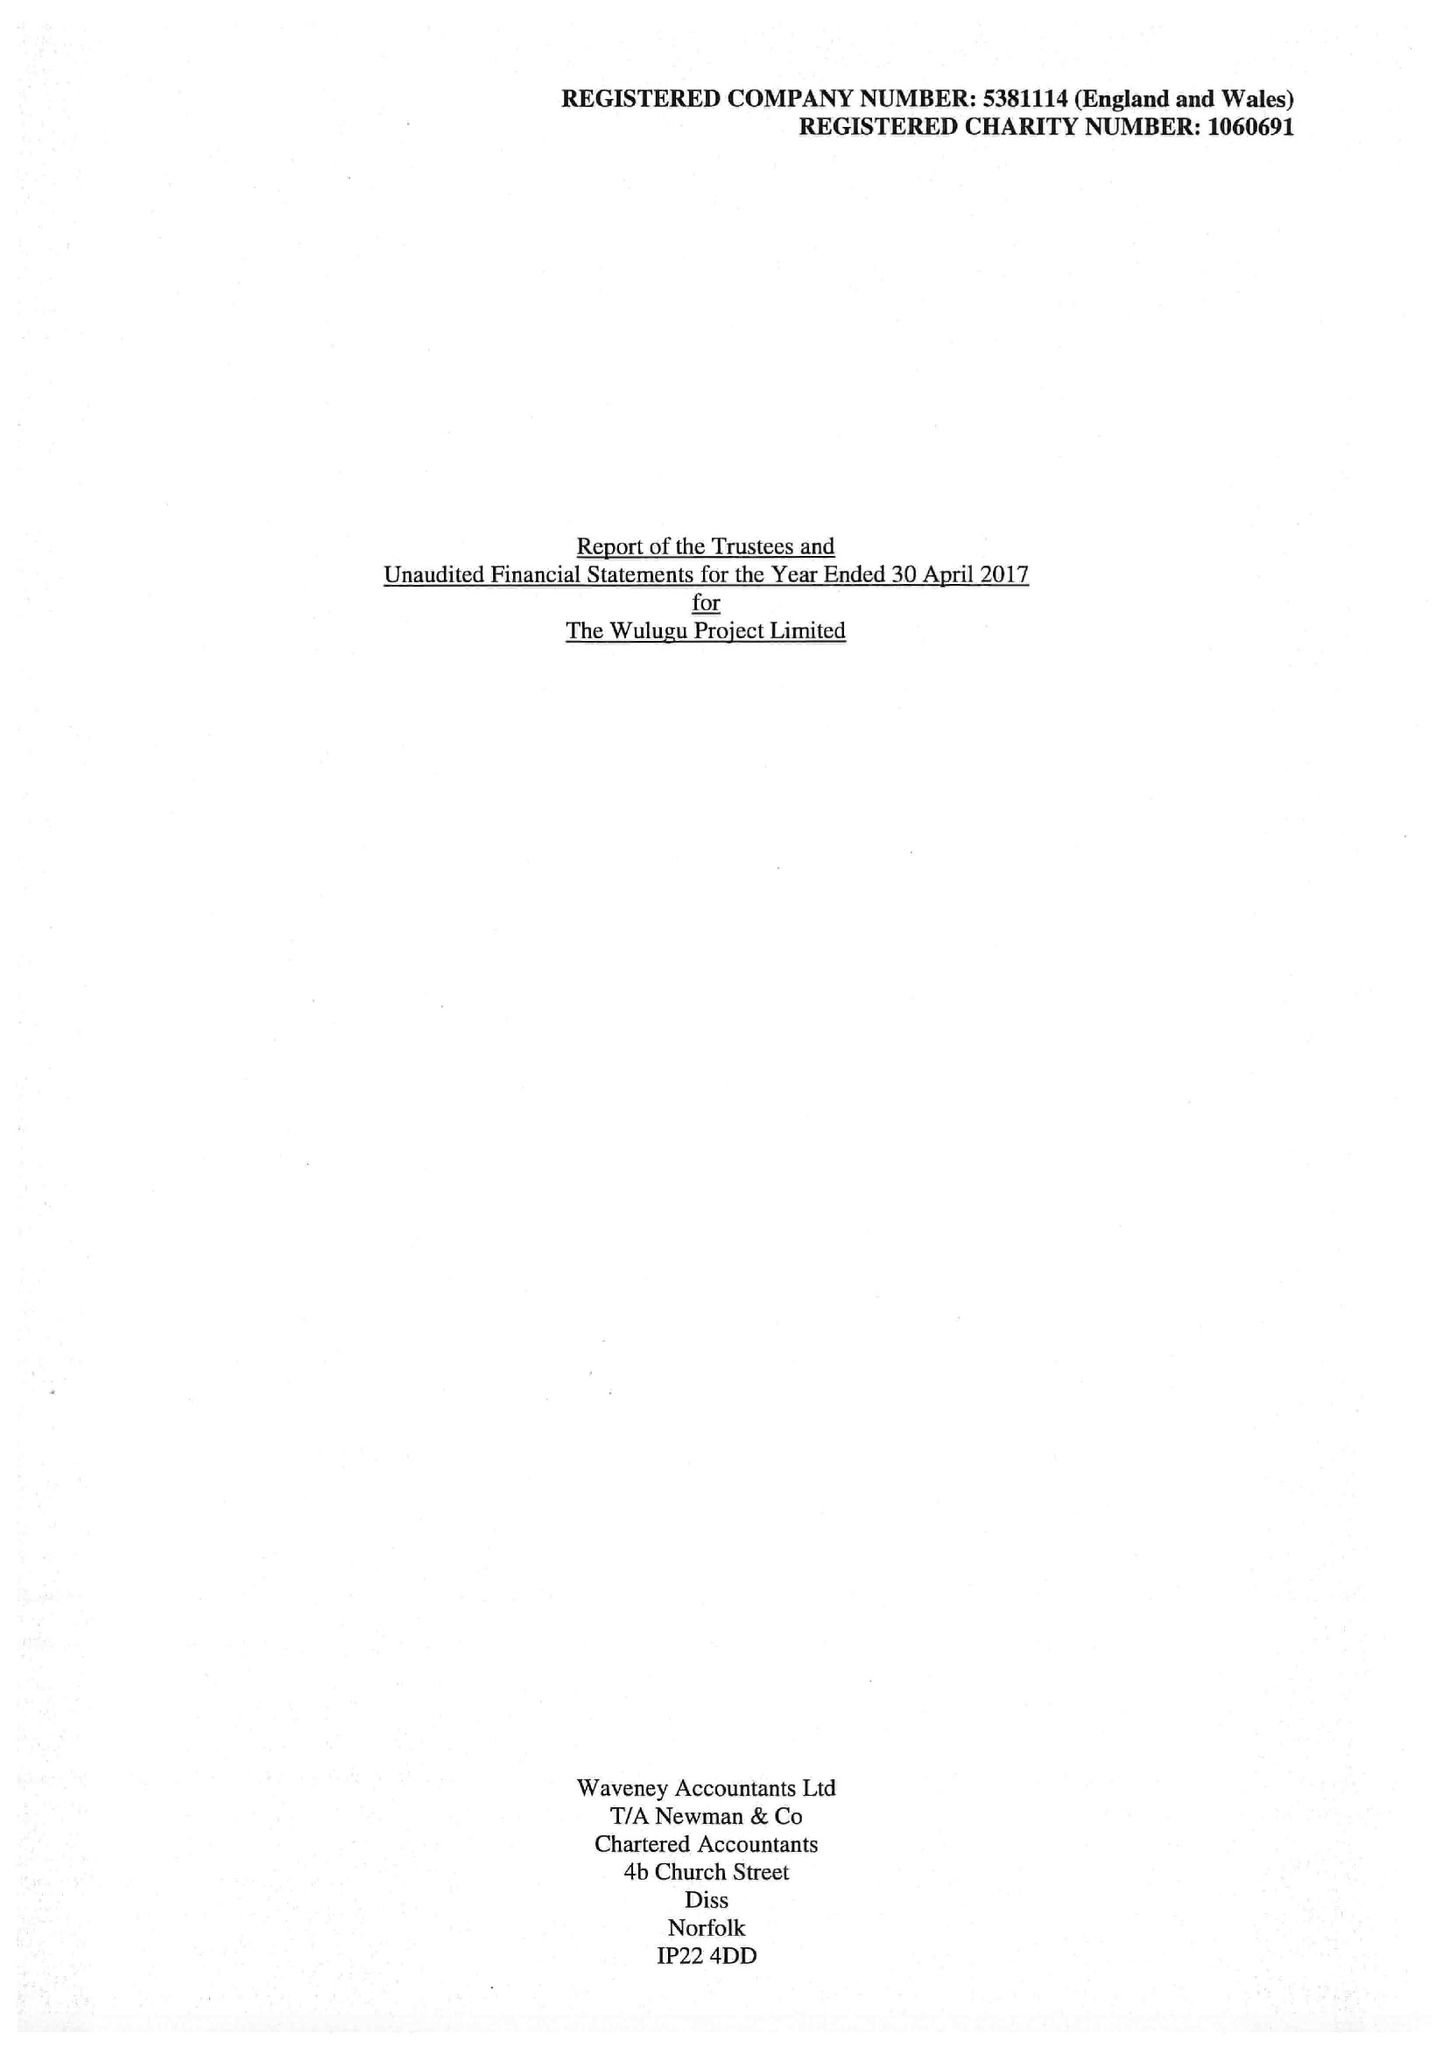What is the value for the income_annually_in_british_pounds?
Answer the question using a single word or phrase. 105493.00 